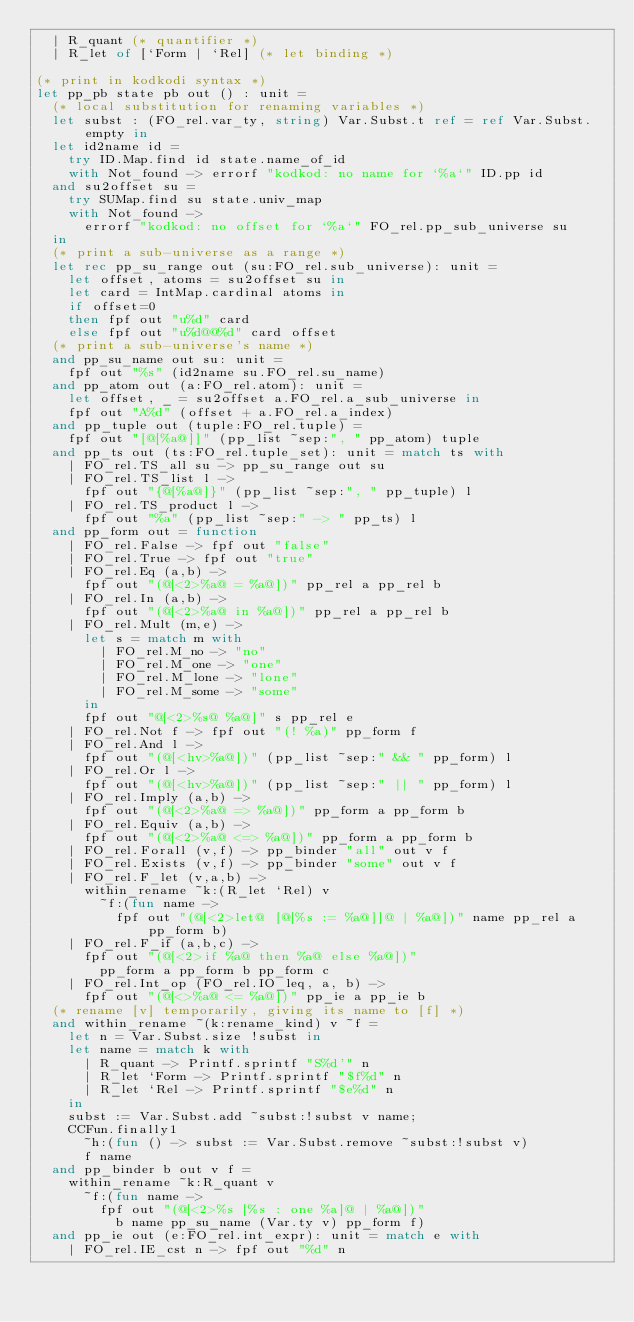<code> <loc_0><loc_0><loc_500><loc_500><_OCaml_>  | R_quant (* quantifier *)
  | R_let of [`Form | `Rel] (* let binding *)

(* print in kodkodi syntax *)
let pp_pb state pb out () : unit =
  (* local substitution for renaming variables *)
  let subst : (FO_rel.var_ty, string) Var.Subst.t ref = ref Var.Subst.empty in
  let id2name id =
    try ID.Map.find id state.name_of_id
    with Not_found -> errorf "kodkod: no name for `%a`" ID.pp id
  and su2offset su =
    try SUMap.find su state.univ_map
    with Not_found ->
      errorf "kodkod: no offset for `%a`" FO_rel.pp_sub_universe su
  in
  (* print a sub-universe as a range *)
  let rec pp_su_range out (su:FO_rel.sub_universe): unit =
    let offset, atoms = su2offset su in
    let card = IntMap.cardinal atoms in
    if offset=0
    then fpf out "u%d" card
    else fpf out "u%d@@%d" card offset
  (* print a sub-universe's name *)
  and pp_su_name out su: unit =
    fpf out "%s" (id2name su.FO_rel.su_name)
  and pp_atom out (a:FO_rel.atom): unit =
    let offset, _ = su2offset a.FO_rel.a_sub_universe in
    fpf out "A%d" (offset + a.FO_rel.a_index)
  and pp_tuple out (tuple:FO_rel.tuple) =
    fpf out "[@[%a@]]" (pp_list ~sep:", " pp_atom) tuple
  and pp_ts out (ts:FO_rel.tuple_set): unit = match ts with
    | FO_rel.TS_all su -> pp_su_range out su
    | FO_rel.TS_list l ->
      fpf out "{@[%a@]}" (pp_list ~sep:", " pp_tuple) l
    | FO_rel.TS_product l ->
      fpf out "%a" (pp_list ~sep:" -> " pp_ts) l
  and pp_form out = function
    | FO_rel.False -> fpf out "false"
    | FO_rel.True -> fpf out "true"
    | FO_rel.Eq (a,b) ->
      fpf out "(@[<2>%a@ = %a@])" pp_rel a pp_rel b
    | FO_rel.In (a,b) ->
      fpf out "(@[<2>%a@ in %a@])" pp_rel a pp_rel b
    | FO_rel.Mult (m,e) ->
      let s = match m with
        | FO_rel.M_no -> "no"
        | FO_rel.M_one -> "one"
        | FO_rel.M_lone -> "lone"
        | FO_rel.M_some -> "some"
      in
      fpf out "@[<2>%s@ %a@]" s pp_rel e
    | FO_rel.Not f -> fpf out "(! %a)" pp_form f
    | FO_rel.And l ->
      fpf out "(@[<hv>%a@])" (pp_list ~sep:" && " pp_form) l
    | FO_rel.Or l ->
      fpf out "(@[<hv>%a@])" (pp_list ~sep:" || " pp_form) l
    | FO_rel.Imply (a,b) ->
      fpf out "(@[<2>%a@ => %a@])" pp_form a pp_form b
    | FO_rel.Equiv (a,b) ->
      fpf out "(@[<2>%a@ <=> %a@])" pp_form a pp_form b
    | FO_rel.Forall (v,f) -> pp_binder "all" out v f
    | FO_rel.Exists (v,f) -> pp_binder "some" out v f
    | FO_rel.F_let (v,a,b) ->
      within_rename ~k:(R_let `Rel) v
        ~f:(fun name ->
          fpf out "(@[<2>let@ [@[%s := %a@]]@ | %a@])" name pp_rel a pp_form b)
    | FO_rel.F_if (a,b,c) ->
      fpf out "(@[<2>if %a@ then %a@ else %a@])"
        pp_form a pp_form b pp_form c
    | FO_rel.Int_op (FO_rel.IO_leq, a, b) ->
      fpf out "(@[<>%a@ <= %a@])" pp_ie a pp_ie b
  (* rename [v] temporarily, giving its name to [f] *)
  and within_rename ~(k:rename_kind) v ~f =
    let n = Var.Subst.size !subst in
    let name = match k with
      | R_quant -> Printf.sprintf "S%d'" n
      | R_let `Form -> Printf.sprintf "$f%d" n
      | R_let `Rel -> Printf.sprintf "$e%d" n
    in
    subst := Var.Subst.add ~subst:!subst v name;
    CCFun.finally1
      ~h:(fun () -> subst := Var.Subst.remove ~subst:!subst v)
      f name
  and pp_binder b out v f =
    within_rename ~k:R_quant v
      ~f:(fun name ->
        fpf out "(@[<2>%s [%s : one %a]@ | %a@])"
          b name pp_su_name (Var.ty v) pp_form f)
  and pp_ie out (e:FO_rel.int_expr): unit = match e with
    | FO_rel.IE_cst n -> fpf out "%d" n</code> 